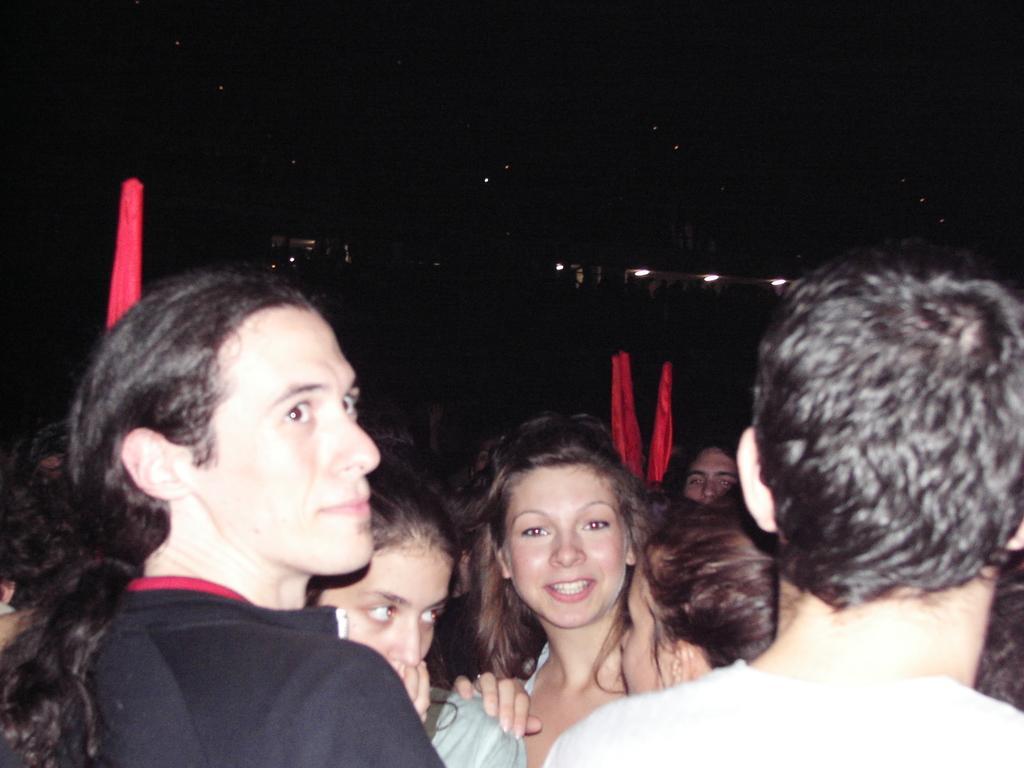Could you give a brief overview of what you see in this image? In the picture we can see some people are standing near to each other and one woman is smiling and one person is looking up and in the background we can see some dark with some lights. 